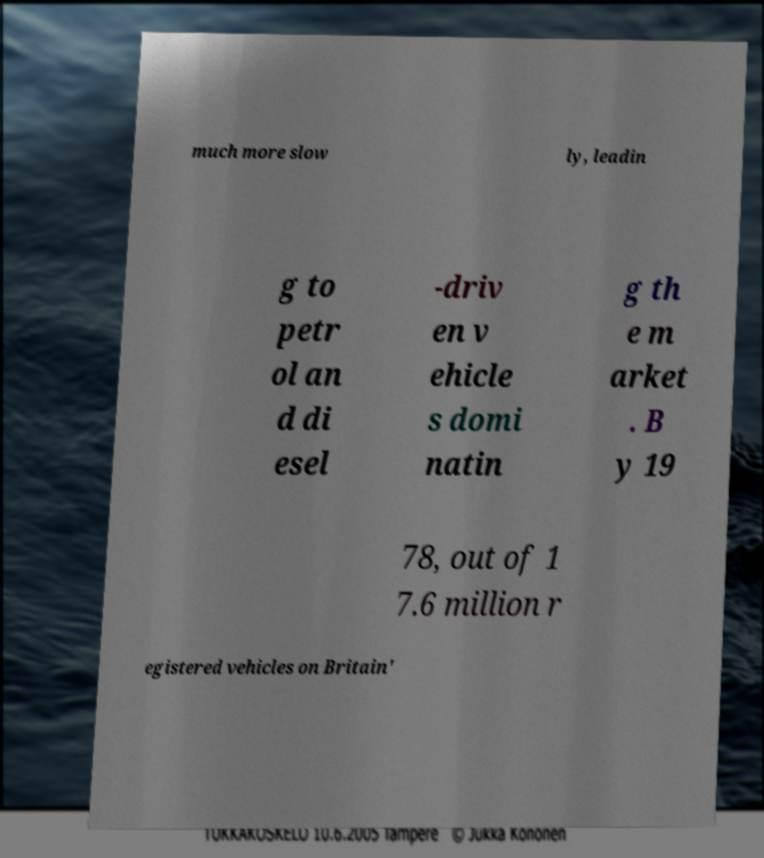For documentation purposes, I need the text within this image transcribed. Could you provide that? much more slow ly, leadin g to petr ol an d di esel -driv en v ehicle s domi natin g th e m arket . B y 19 78, out of 1 7.6 million r egistered vehicles on Britain' 